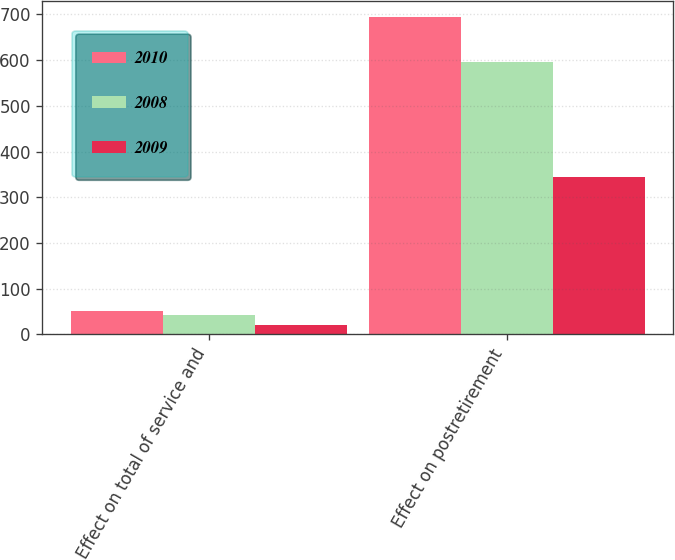Convert chart. <chart><loc_0><loc_0><loc_500><loc_500><stacked_bar_chart><ecel><fcel>Effect on total of service and<fcel>Effect on postretirement<nl><fcel>2010<fcel>52<fcel>695<nl><fcel>2008<fcel>43<fcel>596<nl><fcel>2009<fcel>20<fcel>345<nl></chart> 